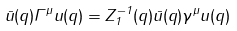Convert formula to latex. <formula><loc_0><loc_0><loc_500><loc_500>\bar { u } ( { q } ) \Gamma ^ { \mu } u ( { q } ) = Z _ { 1 } ^ { - 1 } ( q ) \bar { u } ( { q } ) \gamma ^ { \mu } u ( { q } )</formula> 